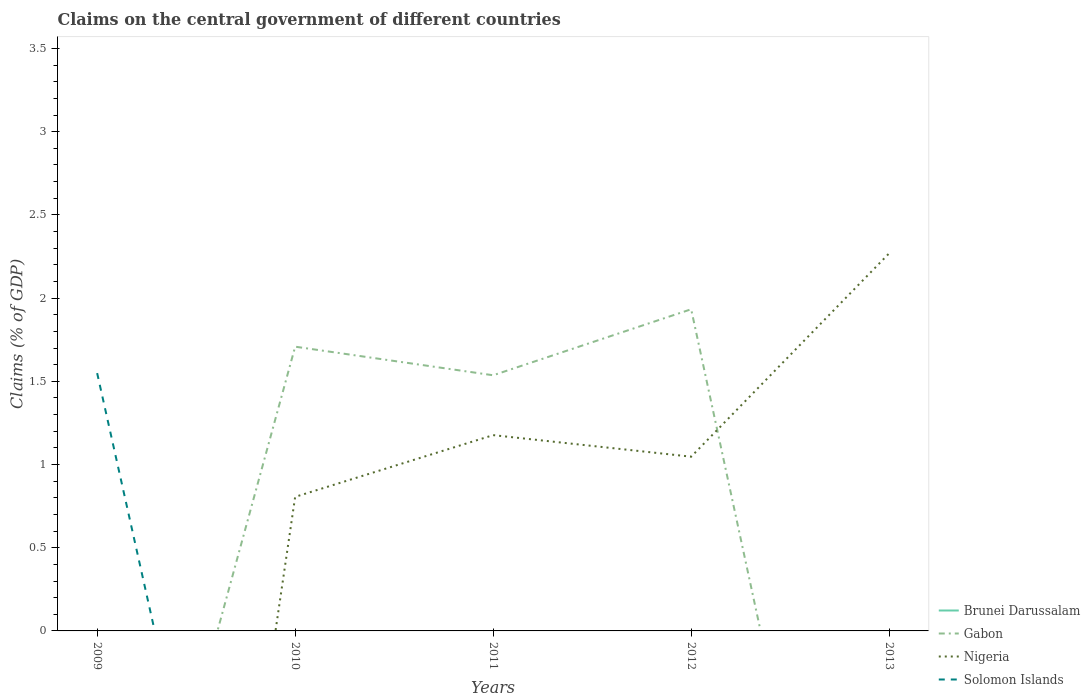Across all years, what is the maximum percentage of GDP claimed on the central government in Gabon?
Give a very brief answer. 0. What is the total percentage of GDP claimed on the central government in Nigeria in the graph?
Make the answer very short. -0.24. What is the difference between the highest and the second highest percentage of GDP claimed on the central government in Solomon Islands?
Make the answer very short. 1.55. Is the percentage of GDP claimed on the central government in Nigeria strictly greater than the percentage of GDP claimed on the central government in Brunei Darussalam over the years?
Keep it short and to the point. No. How many lines are there?
Make the answer very short. 3. What is the difference between two consecutive major ticks on the Y-axis?
Make the answer very short. 0.5. Are the values on the major ticks of Y-axis written in scientific E-notation?
Offer a terse response. No. Does the graph contain any zero values?
Give a very brief answer. Yes. Does the graph contain grids?
Provide a short and direct response. No. Where does the legend appear in the graph?
Your answer should be very brief. Bottom right. What is the title of the graph?
Keep it short and to the point. Claims on the central government of different countries. Does "Sao Tome and Principe" appear as one of the legend labels in the graph?
Ensure brevity in your answer.  No. What is the label or title of the X-axis?
Provide a short and direct response. Years. What is the label or title of the Y-axis?
Give a very brief answer. Claims (% of GDP). What is the Claims (% of GDP) in Gabon in 2009?
Give a very brief answer. 0. What is the Claims (% of GDP) of Solomon Islands in 2009?
Your answer should be very brief. 1.55. What is the Claims (% of GDP) of Brunei Darussalam in 2010?
Offer a very short reply. 0. What is the Claims (% of GDP) in Gabon in 2010?
Ensure brevity in your answer.  1.71. What is the Claims (% of GDP) in Nigeria in 2010?
Your answer should be compact. 0.81. What is the Claims (% of GDP) in Brunei Darussalam in 2011?
Ensure brevity in your answer.  0. What is the Claims (% of GDP) of Gabon in 2011?
Your answer should be very brief. 1.54. What is the Claims (% of GDP) in Nigeria in 2011?
Provide a short and direct response. 1.18. What is the Claims (% of GDP) of Solomon Islands in 2011?
Offer a very short reply. 0. What is the Claims (% of GDP) in Gabon in 2012?
Your answer should be very brief. 1.93. What is the Claims (% of GDP) in Nigeria in 2012?
Offer a very short reply. 1.05. What is the Claims (% of GDP) in Nigeria in 2013?
Offer a very short reply. 2.27. Across all years, what is the maximum Claims (% of GDP) in Gabon?
Offer a terse response. 1.93. Across all years, what is the maximum Claims (% of GDP) of Nigeria?
Your response must be concise. 2.27. Across all years, what is the maximum Claims (% of GDP) of Solomon Islands?
Your response must be concise. 1.55. Across all years, what is the minimum Claims (% of GDP) of Gabon?
Your response must be concise. 0. Across all years, what is the minimum Claims (% of GDP) in Solomon Islands?
Offer a terse response. 0. What is the total Claims (% of GDP) of Gabon in the graph?
Provide a short and direct response. 5.18. What is the total Claims (% of GDP) of Nigeria in the graph?
Provide a succinct answer. 5.3. What is the total Claims (% of GDP) in Solomon Islands in the graph?
Ensure brevity in your answer.  1.55. What is the difference between the Claims (% of GDP) in Gabon in 2010 and that in 2011?
Keep it short and to the point. 0.17. What is the difference between the Claims (% of GDP) of Nigeria in 2010 and that in 2011?
Ensure brevity in your answer.  -0.37. What is the difference between the Claims (% of GDP) of Gabon in 2010 and that in 2012?
Give a very brief answer. -0.22. What is the difference between the Claims (% of GDP) in Nigeria in 2010 and that in 2012?
Offer a terse response. -0.24. What is the difference between the Claims (% of GDP) of Nigeria in 2010 and that in 2013?
Offer a terse response. -1.46. What is the difference between the Claims (% of GDP) of Gabon in 2011 and that in 2012?
Offer a terse response. -0.4. What is the difference between the Claims (% of GDP) of Nigeria in 2011 and that in 2012?
Offer a terse response. 0.13. What is the difference between the Claims (% of GDP) in Nigeria in 2011 and that in 2013?
Provide a short and direct response. -1.09. What is the difference between the Claims (% of GDP) in Nigeria in 2012 and that in 2013?
Provide a succinct answer. -1.22. What is the difference between the Claims (% of GDP) in Gabon in 2010 and the Claims (% of GDP) in Nigeria in 2011?
Provide a succinct answer. 0.53. What is the difference between the Claims (% of GDP) in Gabon in 2010 and the Claims (% of GDP) in Nigeria in 2012?
Offer a terse response. 0.66. What is the difference between the Claims (% of GDP) in Gabon in 2010 and the Claims (% of GDP) in Nigeria in 2013?
Offer a terse response. -0.56. What is the difference between the Claims (% of GDP) of Gabon in 2011 and the Claims (% of GDP) of Nigeria in 2012?
Provide a succinct answer. 0.49. What is the difference between the Claims (% of GDP) of Gabon in 2011 and the Claims (% of GDP) of Nigeria in 2013?
Make the answer very short. -0.73. What is the difference between the Claims (% of GDP) of Gabon in 2012 and the Claims (% of GDP) of Nigeria in 2013?
Make the answer very short. -0.34. What is the average Claims (% of GDP) of Brunei Darussalam per year?
Ensure brevity in your answer.  0. What is the average Claims (% of GDP) in Gabon per year?
Provide a short and direct response. 1.04. What is the average Claims (% of GDP) in Nigeria per year?
Keep it short and to the point. 1.06. What is the average Claims (% of GDP) of Solomon Islands per year?
Provide a succinct answer. 0.31. In the year 2010, what is the difference between the Claims (% of GDP) in Gabon and Claims (% of GDP) in Nigeria?
Your answer should be compact. 0.9. In the year 2011, what is the difference between the Claims (% of GDP) in Gabon and Claims (% of GDP) in Nigeria?
Offer a terse response. 0.36. In the year 2012, what is the difference between the Claims (% of GDP) of Gabon and Claims (% of GDP) of Nigeria?
Make the answer very short. 0.89. What is the ratio of the Claims (% of GDP) in Gabon in 2010 to that in 2011?
Offer a very short reply. 1.11. What is the ratio of the Claims (% of GDP) in Nigeria in 2010 to that in 2011?
Your response must be concise. 0.68. What is the ratio of the Claims (% of GDP) in Gabon in 2010 to that in 2012?
Offer a terse response. 0.88. What is the ratio of the Claims (% of GDP) of Nigeria in 2010 to that in 2012?
Your response must be concise. 0.77. What is the ratio of the Claims (% of GDP) of Nigeria in 2010 to that in 2013?
Give a very brief answer. 0.35. What is the ratio of the Claims (% of GDP) of Gabon in 2011 to that in 2012?
Ensure brevity in your answer.  0.79. What is the ratio of the Claims (% of GDP) of Nigeria in 2011 to that in 2012?
Ensure brevity in your answer.  1.12. What is the ratio of the Claims (% of GDP) of Nigeria in 2011 to that in 2013?
Provide a short and direct response. 0.52. What is the ratio of the Claims (% of GDP) of Nigeria in 2012 to that in 2013?
Provide a succinct answer. 0.46. What is the difference between the highest and the second highest Claims (% of GDP) in Gabon?
Offer a terse response. 0.22. What is the difference between the highest and the second highest Claims (% of GDP) of Nigeria?
Ensure brevity in your answer.  1.09. What is the difference between the highest and the lowest Claims (% of GDP) of Gabon?
Provide a succinct answer. 1.93. What is the difference between the highest and the lowest Claims (% of GDP) in Nigeria?
Make the answer very short. 2.27. What is the difference between the highest and the lowest Claims (% of GDP) of Solomon Islands?
Your answer should be very brief. 1.55. 